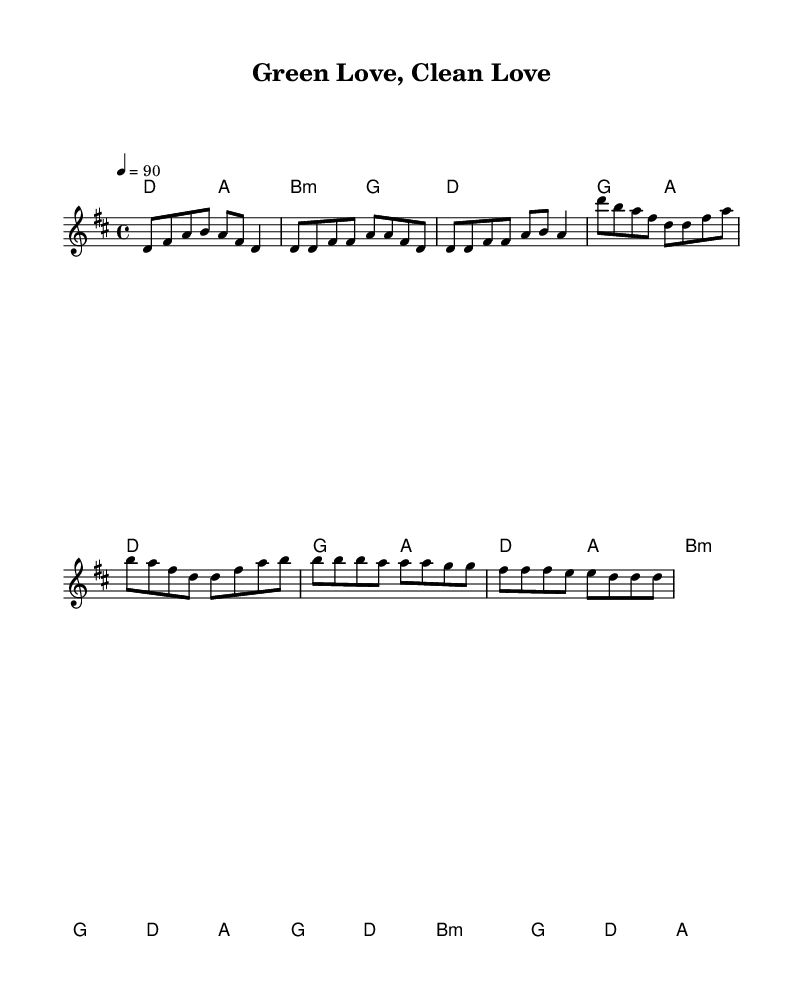What is the key signature of this music? The key signature is indicated at the beginning of the staff, which shows two sharps (F# and C#). This corresponds to the key of D major.
Answer: D major What is the time signature of this music? The time signature is found at the beginning of the sheet music next to the key signature. It is written as 4/4, indicating there are four beats in each measure and the quarter note gets one beat.
Answer: 4/4 What is the tempo marking for this piece? The tempo marking is indicated with the term "tempo" followed by a number, which represents beats per minute. In this piece, it is marked as "4 = 90", meaning the quarter note should be played at a speed of 90 beats per minute.
Answer: 90 How many measures are in the verse section? The verse section consists of two segments as outlined in the melody; each segment has four measures, resulting in a total of eight measures.
Answer: 8 What is the primary theme of the lyrics? The lyrics convey messages about recycling and making sustainable choices. Specifically, phrases about "recycling bins" and "solar panels" indicate a focus on environmental responsibility.
Answer: Eco-consciousness How many distinct sections does this song have? Upon reviewing the structure, it is clear that the song includes four distinct sections: Intro, Verse, Chorus, and Bridge, which showcase different musical content.
Answer: 4 What type of chords are used in the chorus? The chords in the chorus are primarily diatonic, which means they are built on the notes of the D major scale. The use of D major, A minor, and B minor chords contributes to the harmonic flavor typical in R&B music.
Answer: Diatonic 